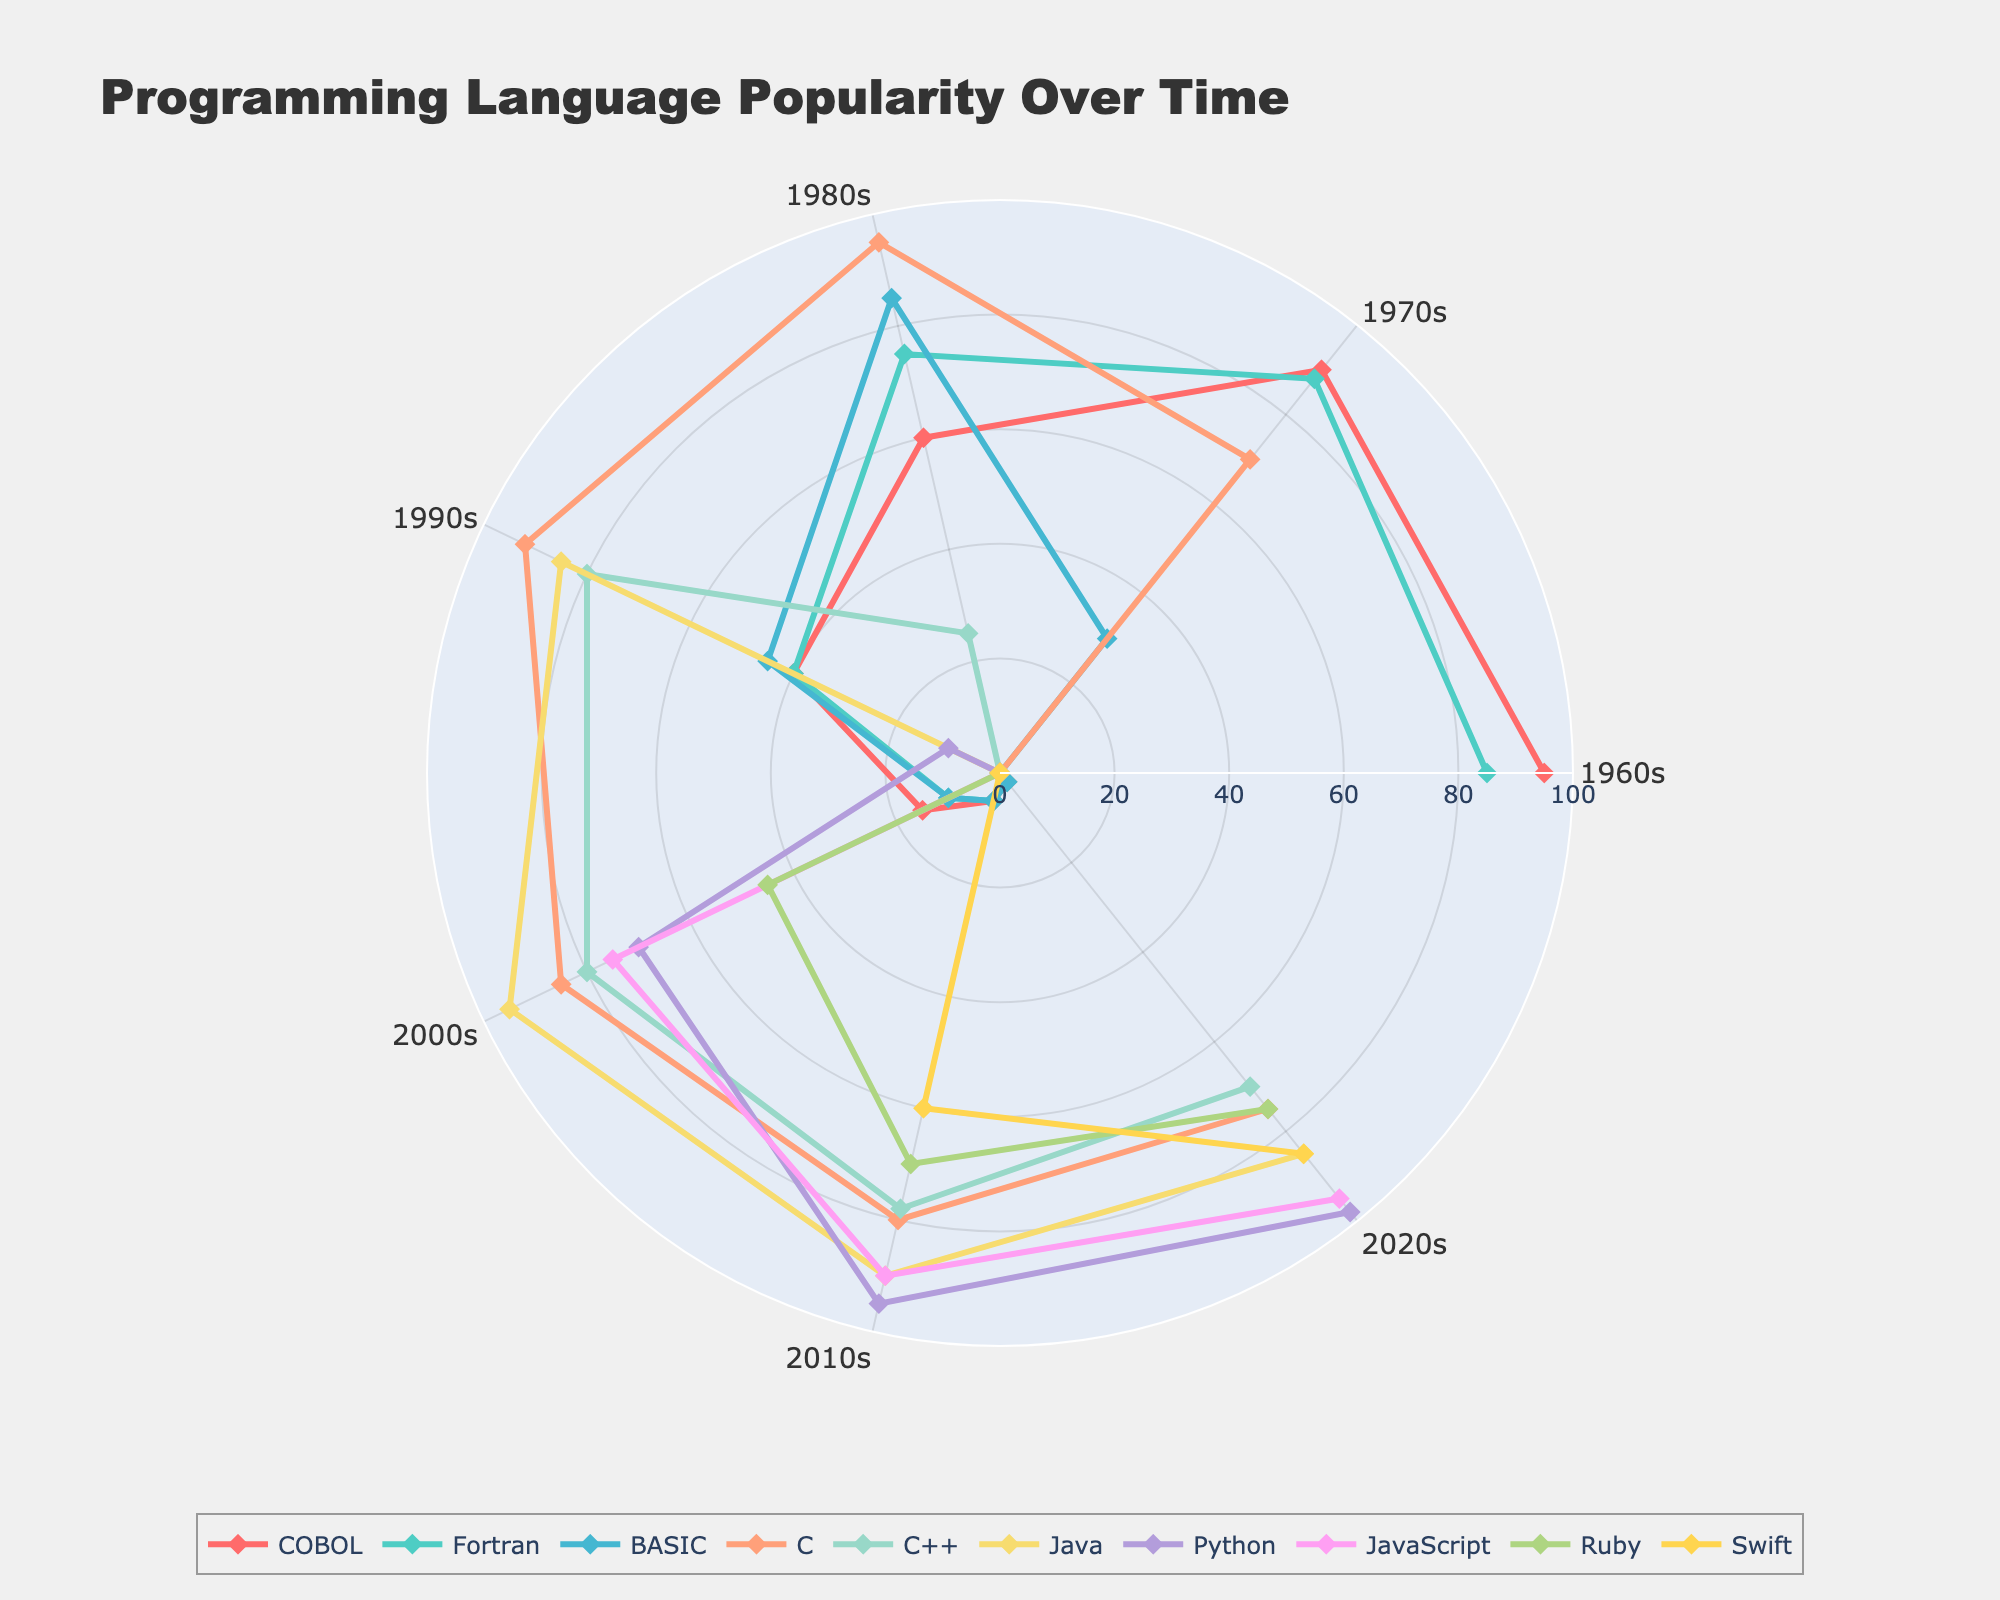What is the title of the figure? The title of the figure is displayed at the top of the chart. Reading it directly gives us the answer.
Answer: Programming Language Popularity Over Time Which decade shows the highest popularity for the BASIC programming language? Observing the radii of the data points for BASIC across all decades, we see that the 1980s have the maximum value (85).
Answer: 1980s How does the popularity of JavaScript in the 2010s compare to its popularity in the 2000s? We look at the radii corresponding to JavaScript in the 2000s and 2010s. In the 2000s, it is 75, and in the 2010s, it is 90. So, it increased by 15 points.
Answer: Higher in the 2010s Which programming language had the sharpest decline in popularity from the 1960s to the 2020s? By comparing the values from the 1960s to the 2020s for all languages, COBOL decreased from 95 to 2, which is the sharpest decline (93 points).
Answer: COBOL What is the average popularity of C++ throughout all decades? The values for C++ are 0, 0, 25, 80, 80, 78, and 70. The sum is 333, and there are 7 data points, so 333 / 7 = 47.57 (rounded to two decimal places).
Answer: 47.57 Between which consecutive decades did C++ see the highest increase in popularity? Checking the changes between consecutive decades for C++, the highest increase is between the 1980s (25) and 1990s (80), which is an increase of 55 points.
Answer: 1980s to 1990s Which decade experienced the most diversified popularity in programming languages (i.e., the greatest range between the highest and lowest values)? Calculating the range for each decade: 1960s (95-0=95), 1970s (90-0=90), 1980s (95-0=95), 1990s (92-0=92), 2000s (95-0=95), 2010s (95-5=90), 2020s (98-2=96). The 2020s have the greatest range (96).
Answer: 2020s 